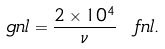Convert formula to latex. <formula><loc_0><loc_0><loc_500><loc_500>\ g n l = \frac { 2 \times 1 0 ^ { 4 } } { \nu } \ f n l .</formula> 